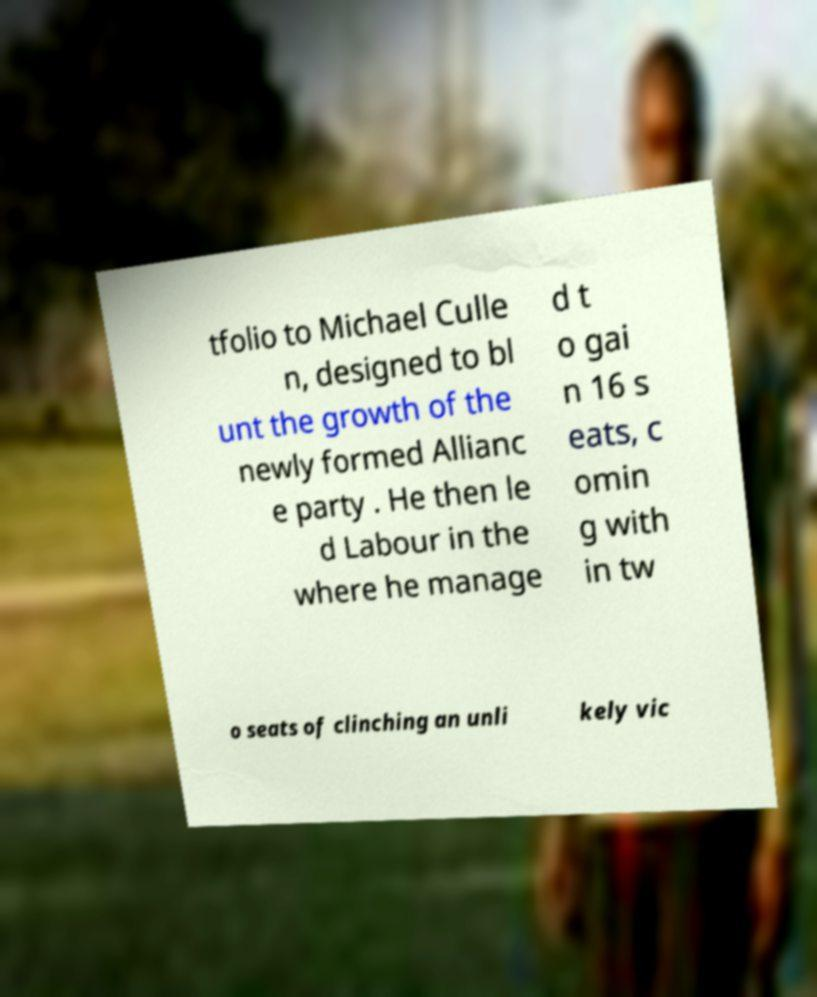What messages or text are displayed in this image? I need them in a readable, typed format. tfolio to Michael Culle n, designed to bl unt the growth of the newly formed Allianc e party . He then le d Labour in the where he manage d t o gai n 16 s eats, c omin g with in tw o seats of clinching an unli kely vic 